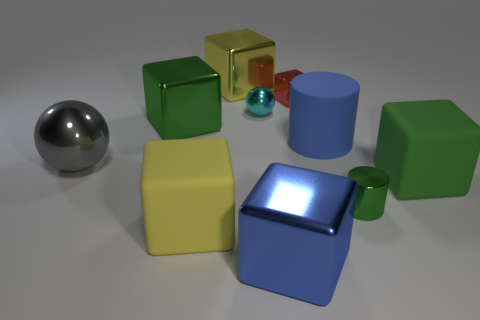There is a cylinder that is behind the block on the right side of the large cylinder; what is its color?
Ensure brevity in your answer.  Blue. Are there fewer big gray shiny balls on the right side of the large gray metal sphere than tiny red metallic cubes that are behind the big blue metallic object?
Your answer should be very brief. Yes. Do the green shiny cube and the green shiny cylinder have the same size?
Your answer should be compact. No. There is a rubber object that is to the right of the small red cube and in front of the large rubber cylinder; what is its shape?
Offer a very short reply. Cube. What number of gray balls have the same material as the big blue cube?
Your answer should be very brief. 1. There is a blue shiny cube that is in front of the big green metal object; how many blue shiny objects are behind it?
Make the answer very short. 0. The green metallic thing that is behind the shiny sphere left of the large yellow object behind the big gray thing is what shape?
Ensure brevity in your answer.  Cube. What is the size of the metal thing that is the same color as the tiny metal cylinder?
Your answer should be very brief. Large. How many objects are either gray objects or green matte cubes?
Offer a terse response. 2. The cylinder that is the same size as the red metallic block is what color?
Ensure brevity in your answer.  Green. 